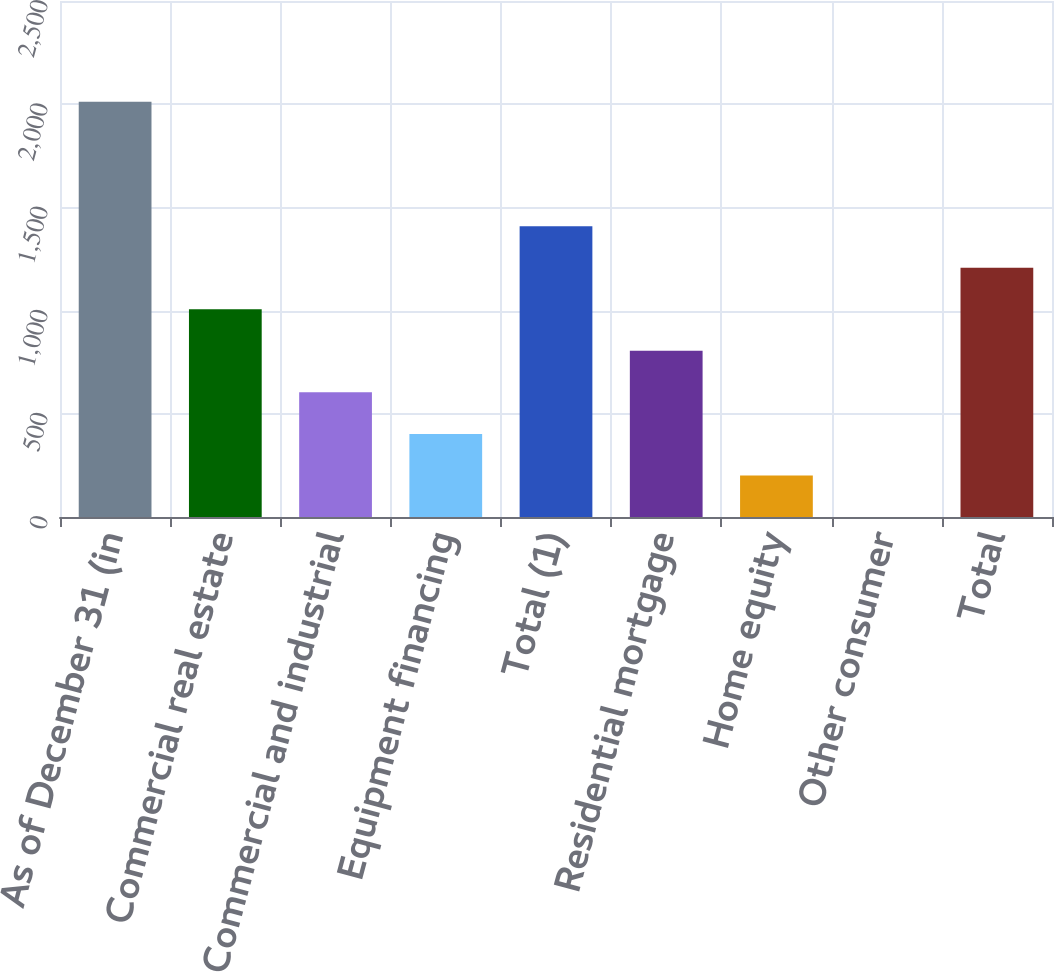<chart> <loc_0><loc_0><loc_500><loc_500><bar_chart><fcel>As of December 31 (in<fcel>Commercial real estate<fcel>Commercial and industrial<fcel>Equipment financing<fcel>Total (1)<fcel>Residential mortgage<fcel>Home equity<fcel>Other consumer<fcel>Total<nl><fcel>2012<fcel>1006.15<fcel>603.81<fcel>402.64<fcel>1408.49<fcel>804.98<fcel>201.47<fcel>0.3<fcel>1207.32<nl></chart> 